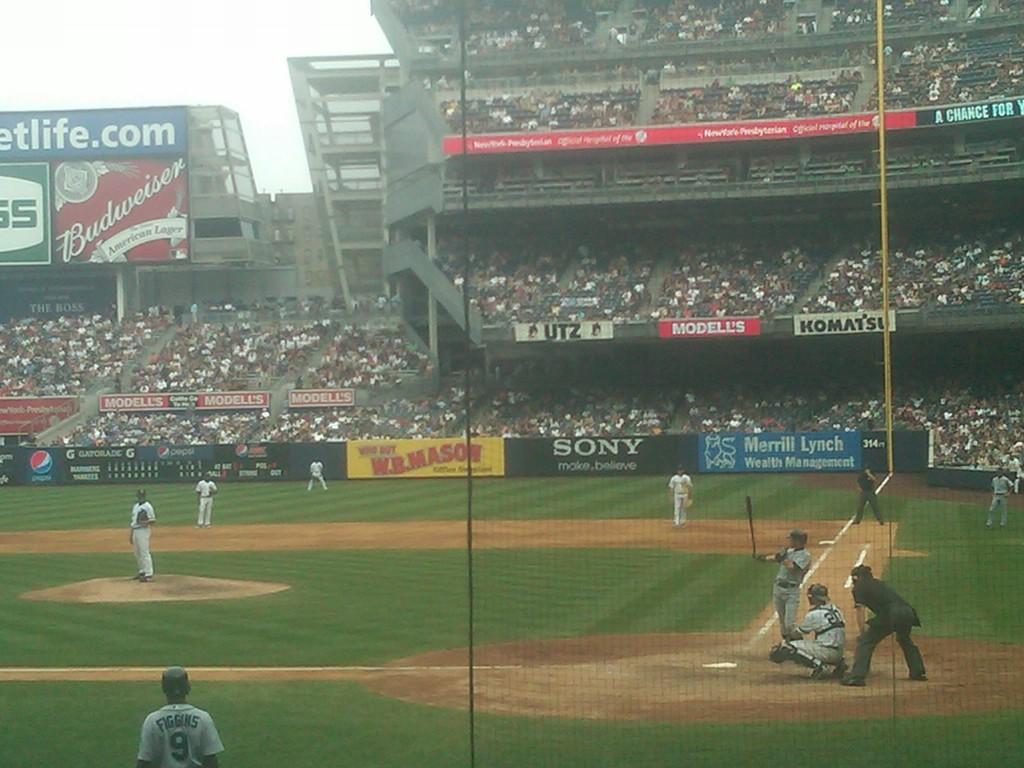What brand is in black?
Offer a very short reply. Sony. 